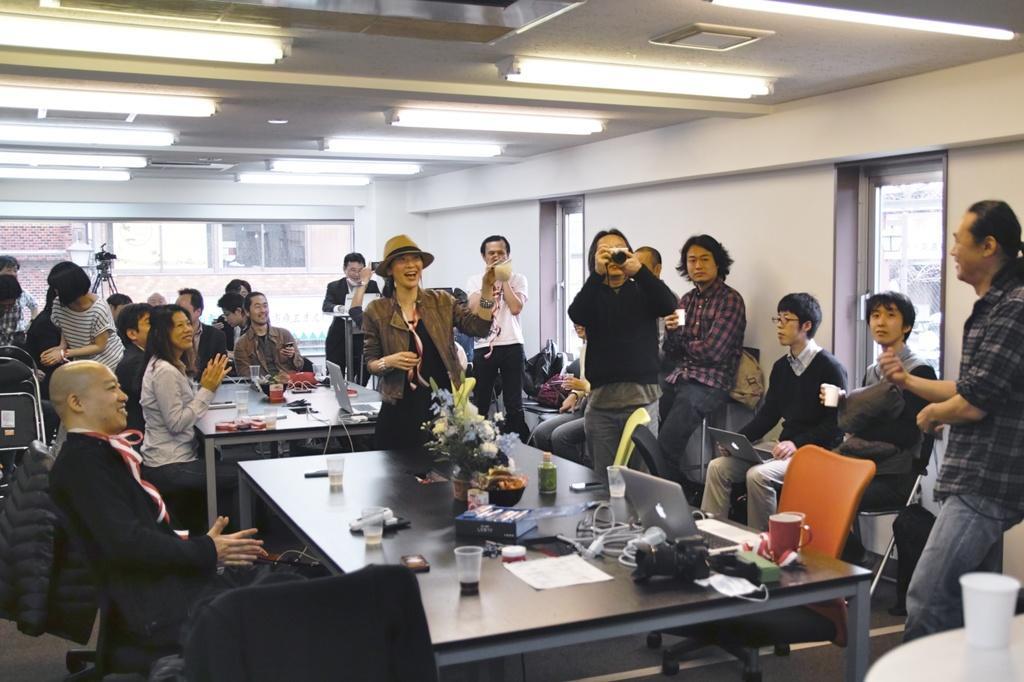How would you summarize this image in a sentence or two? In this picture there are a group of people standing and also some people are sitting they have a table in front of them which has a small plant, laptop, cables, glasses, books tissues, coffee mugs etc. 